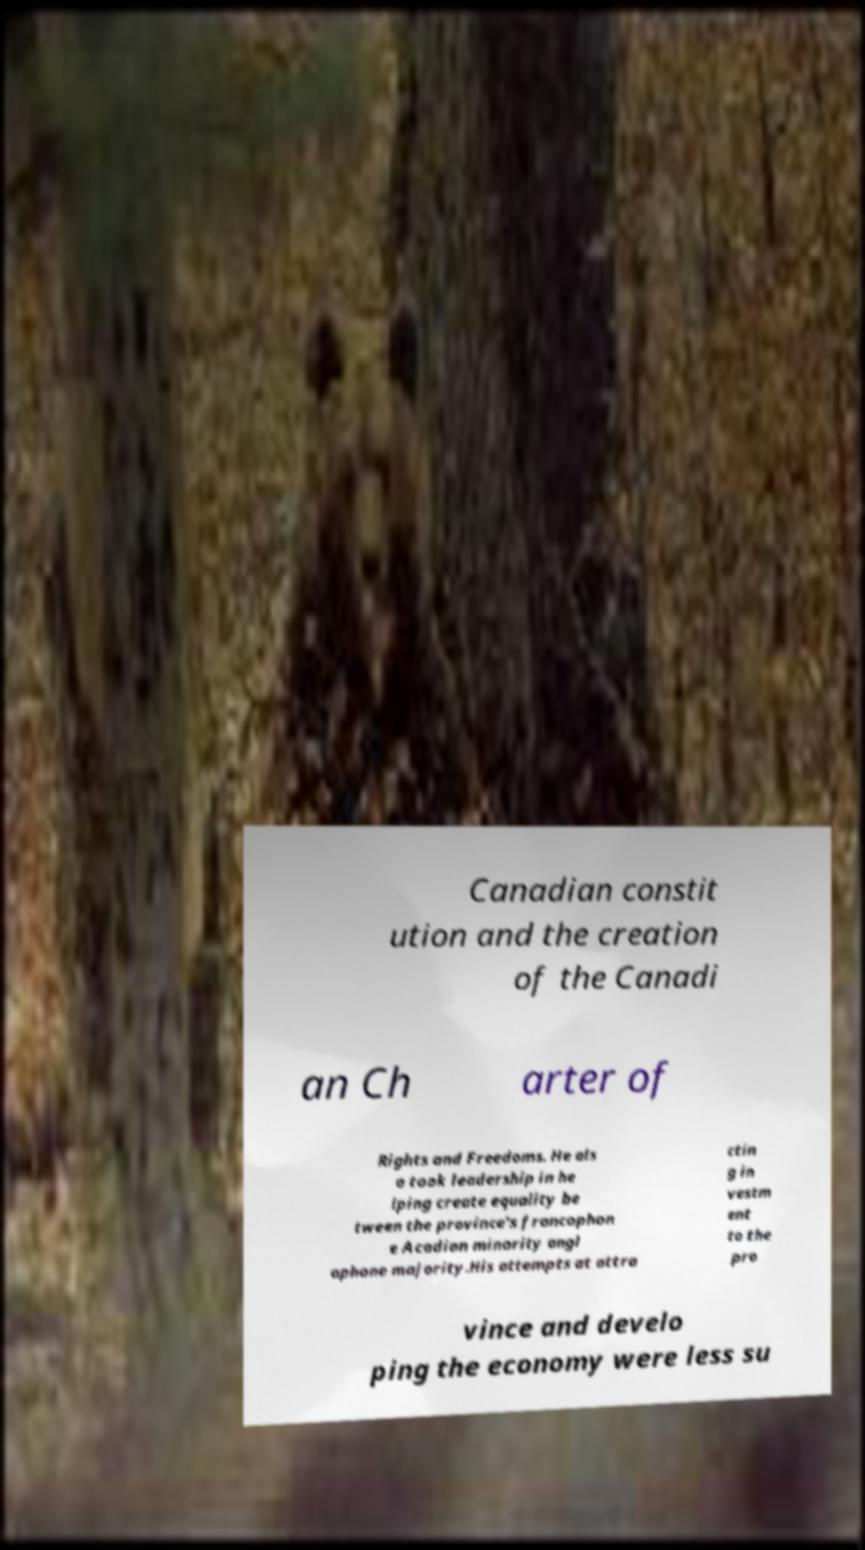Please read and relay the text visible in this image. What does it say? Canadian constit ution and the creation of the Canadi an Ch arter of Rights and Freedoms. He als o took leadership in he lping create equality be tween the province's francophon e Acadian minority angl ophone majority.His attempts at attra ctin g in vestm ent to the pro vince and develo ping the economy were less su 